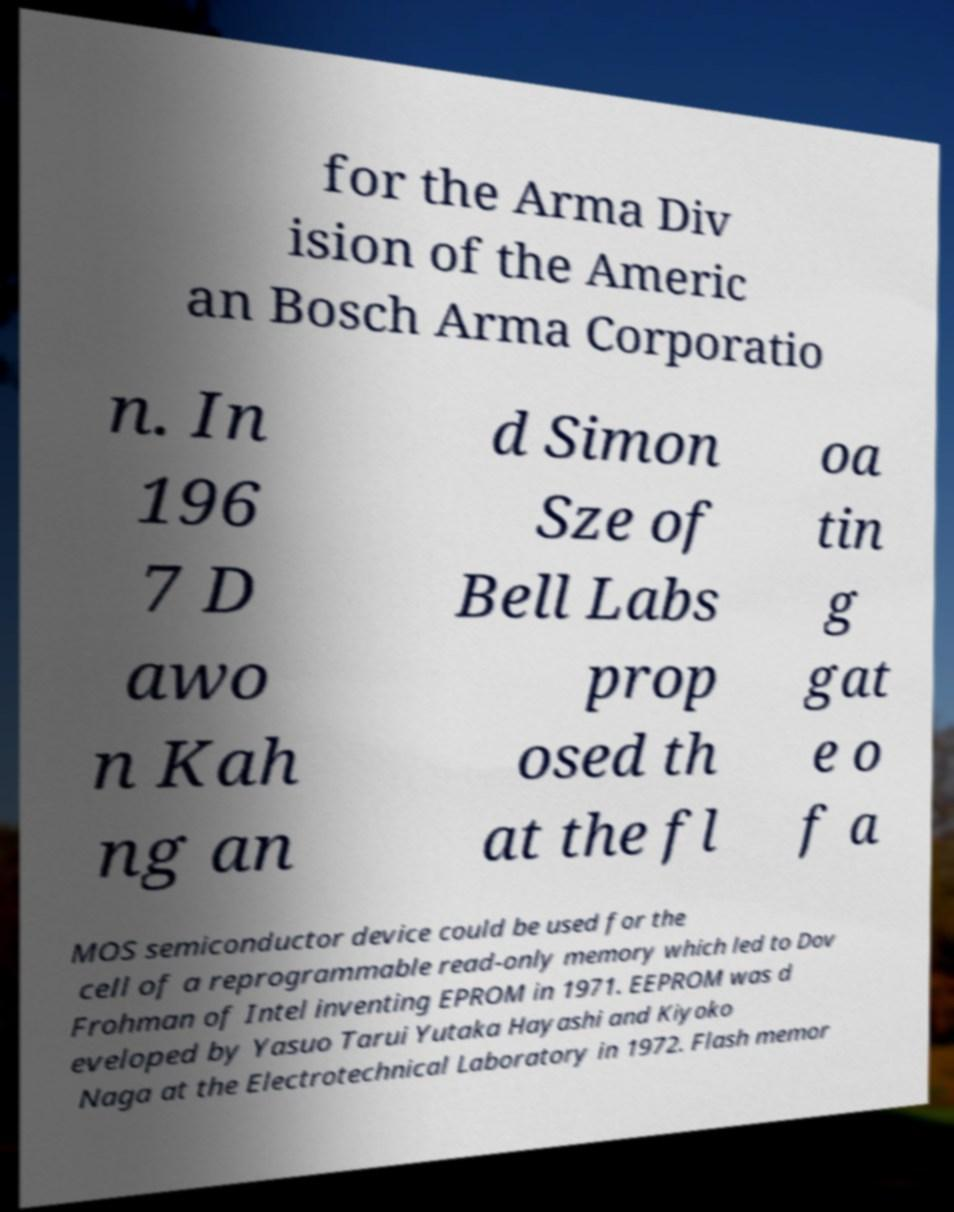For documentation purposes, I need the text within this image transcribed. Could you provide that? for the Arma Div ision of the Americ an Bosch Arma Corporatio n. In 196 7 D awo n Kah ng an d Simon Sze of Bell Labs prop osed th at the fl oa tin g gat e o f a MOS semiconductor device could be used for the cell of a reprogrammable read-only memory which led to Dov Frohman of Intel inventing EPROM in 1971. EEPROM was d eveloped by Yasuo Tarui Yutaka Hayashi and Kiyoko Naga at the Electrotechnical Laboratory in 1972. Flash memor 